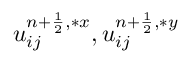Convert formula to latex. <formula><loc_0><loc_0><loc_500><loc_500>u _ { i j } ^ { n + \frac { 1 } { 2 } , \ast x } , u _ { i j } ^ { n + \frac { 1 } { 2 } , \ast y }</formula> 